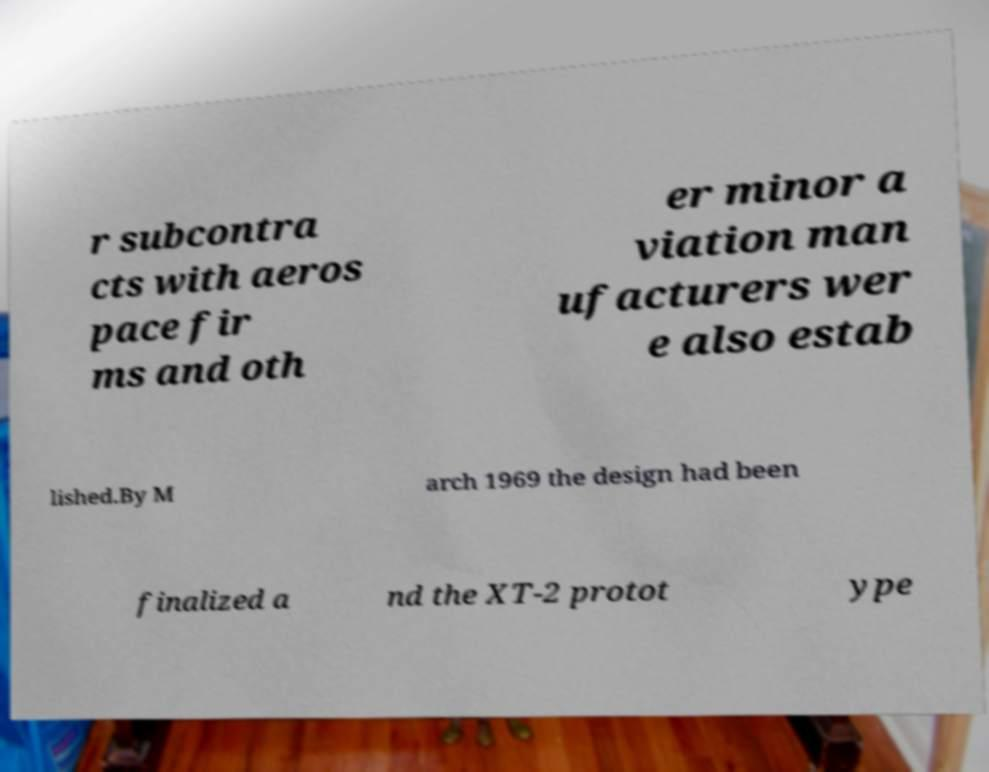For documentation purposes, I need the text within this image transcribed. Could you provide that? r subcontra cts with aeros pace fir ms and oth er minor a viation man ufacturers wer e also estab lished.By M arch 1969 the design had been finalized a nd the XT-2 protot ype 